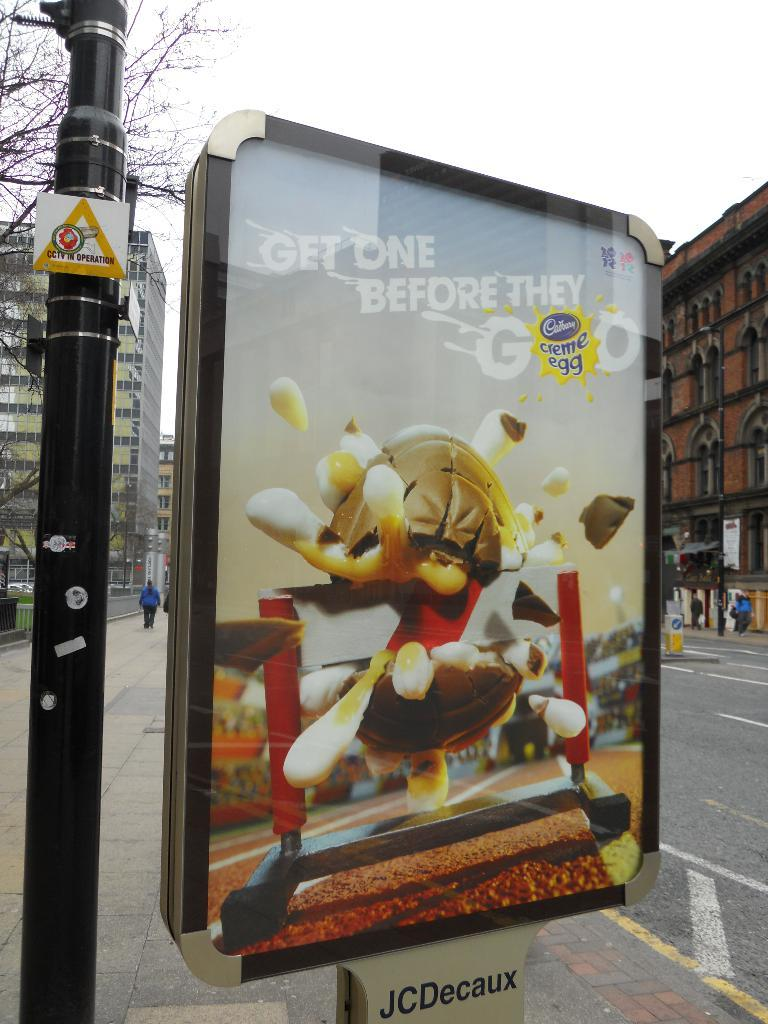<image>
Share a concise interpretation of the image provided. An advertisement board for Cadbury Creme eggs is along a street. 